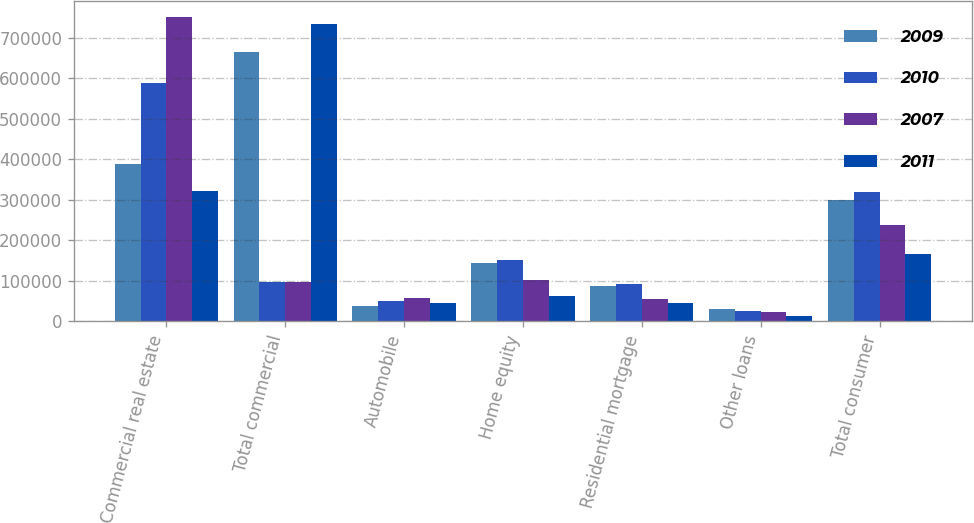<chart> <loc_0><loc_0><loc_500><loc_500><stacked_bar_chart><ecel><fcel>Commercial real estate<fcel>Total commercial<fcel>Automobile<fcel>Home equity<fcel>Residential mortgage<fcel>Other loans<fcel>Total consumer<nl><fcel>2009<fcel>388706<fcel>664073<fcel>38282<fcel>143873<fcel>87194<fcel>31406<fcel>300755<nl><fcel>2010<fcel>588251<fcel>97664<fcel>49488<fcel>150630<fcel>93289<fcel>26736<fcel>320143<nl><fcel>2007<fcel>751875<fcel>97664<fcel>57951<fcel>102039<fcel>55903<fcel>22506<fcel>238399<nl><fcel>2011<fcel>322681<fcel>734882<fcel>44712<fcel>63538<fcel>44463<fcel>12632<fcel>165345<nl></chart> 